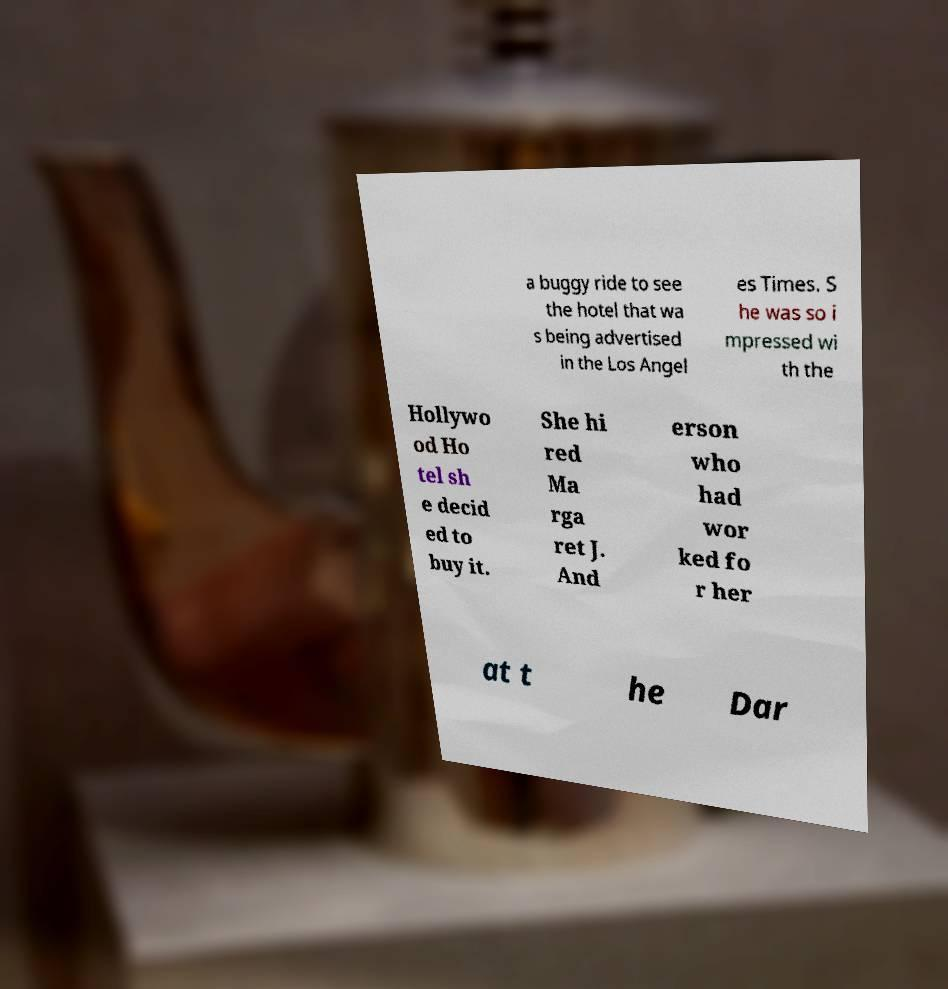Please read and relay the text visible in this image. What does it say? a buggy ride to see the hotel that wa s being advertised in the Los Angel es Times. S he was so i mpressed wi th the Hollywo od Ho tel sh e decid ed to buy it. She hi red Ma rga ret J. And erson who had wor ked fo r her at t he Dar 